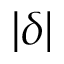<formula> <loc_0><loc_0><loc_500><loc_500>| \delta |</formula> 